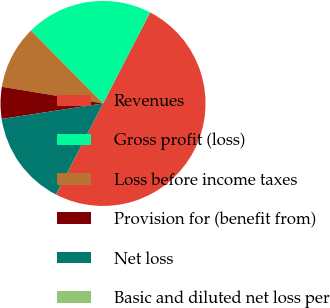Convert chart. <chart><loc_0><loc_0><loc_500><loc_500><pie_chart><fcel>Revenues<fcel>Gross profit (loss)<fcel>Loss before income taxes<fcel>Provision for (benefit from)<fcel>Net loss<fcel>Basic and diluted net loss per<nl><fcel>49.98%<fcel>20.0%<fcel>10.0%<fcel>5.01%<fcel>15.0%<fcel>0.01%<nl></chart> 